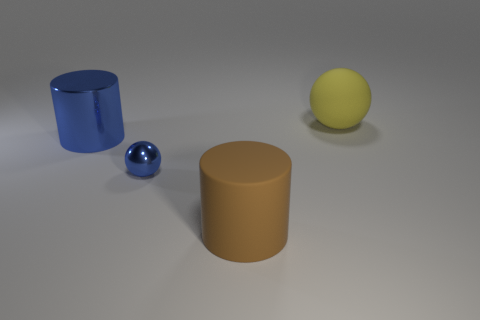What is the color of the big thing that is made of the same material as the big brown cylinder?
Offer a very short reply. Yellow. What number of large metal cylinders have the same color as the tiny sphere?
Offer a terse response. 1. There is a object that is both in front of the blue metal cylinder and on the right side of the blue sphere; what is its size?
Your answer should be compact. Large. Are the big yellow sphere and the brown cylinder made of the same material?
Keep it short and to the point. Yes. There is another thing that is the same shape as the small metallic object; what is its size?
Offer a very short reply. Large. What is the brown thing made of?
Ensure brevity in your answer.  Rubber. Do the large cylinder in front of the big blue metallic cylinder and the big metallic object have the same color?
Provide a succinct answer. No. Is there any other thing that has the same shape as the large brown object?
Your answer should be very brief. Yes. There is another thing that is the same shape as the big brown matte thing; what color is it?
Your answer should be very brief. Blue. What is the material of the cylinder behind the tiny metal sphere?
Ensure brevity in your answer.  Metal. 